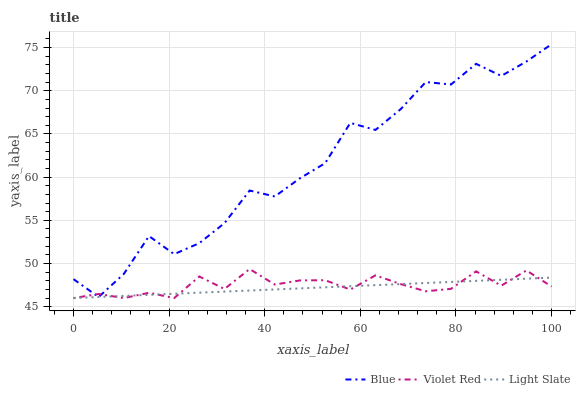Does Light Slate have the minimum area under the curve?
Answer yes or no. Yes. Does Blue have the maximum area under the curve?
Answer yes or no. Yes. Does Violet Red have the minimum area under the curve?
Answer yes or no. No. Does Violet Red have the maximum area under the curve?
Answer yes or no. No. Is Light Slate the smoothest?
Answer yes or no. Yes. Is Blue the roughest?
Answer yes or no. Yes. Is Violet Red the smoothest?
Answer yes or no. No. Is Violet Red the roughest?
Answer yes or no. No. Does Light Slate have the lowest value?
Answer yes or no. Yes. Does Blue have the highest value?
Answer yes or no. Yes. Does Violet Red have the highest value?
Answer yes or no. No. Does Violet Red intersect Light Slate?
Answer yes or no. Yes. Is Violet Red less than Light Slate?
Answer yes or no. No. Is Violet Red greater than Light Slate?
Answer yes or no. No. 